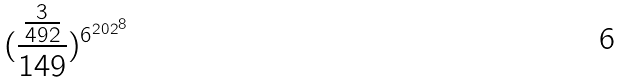<formula> <loc_0><loc_0><loc_500><loc_500>( \frac { \frac { 3 } { 4 9 2 } } { 1 4 9 } ) ^ { { 6 ^ { 2 0 2 } } ^ { 8 } }</formula> 